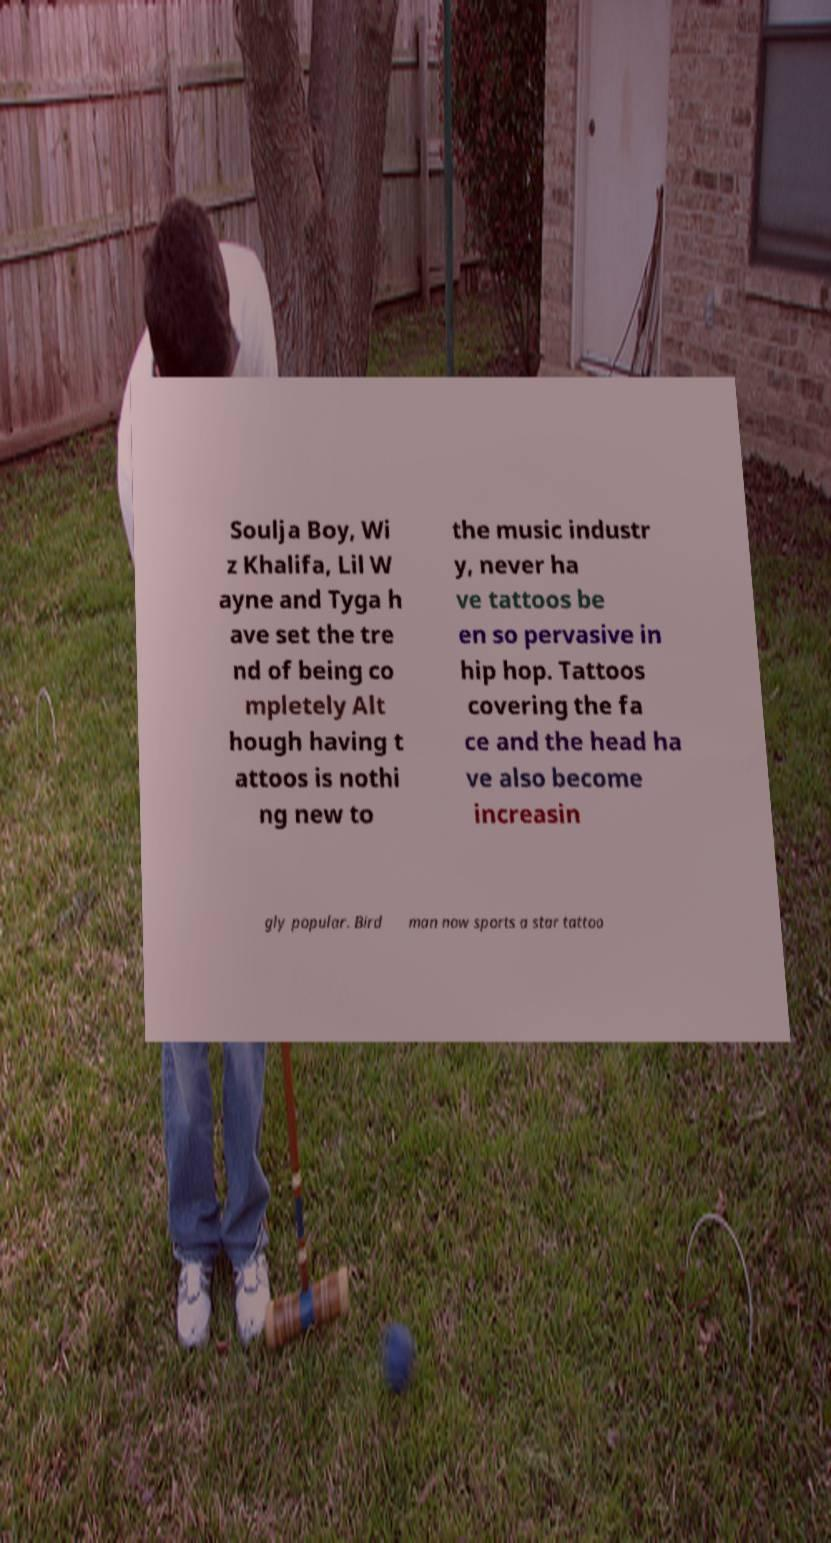Please read and relay the text visible in this image. What does it say? Soulja Boy, Wi z Khalifa, Lil W ayne and Tyga h ave set the tre nd of being co mpletely Alt hough having t attoos is nothi ng new to the music industr y, never ha ve tattoos be en so pervasive in hip hop. Tattoos covering the fa ce and the head ha ve also become increasin gly popular. Bird man now sports a star tattoo 